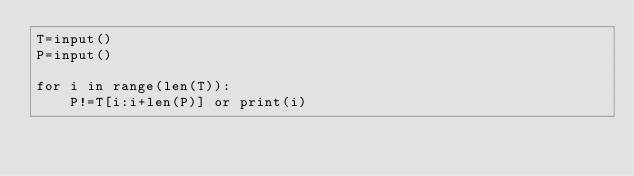Convert code to text. <code><loc_0><loc_0><loc_500><loc_500><_Python_>T=input()
P=input()

for i in range(len(T)):
    P!=T[i:i+len(P)] or print(i)
</code> 